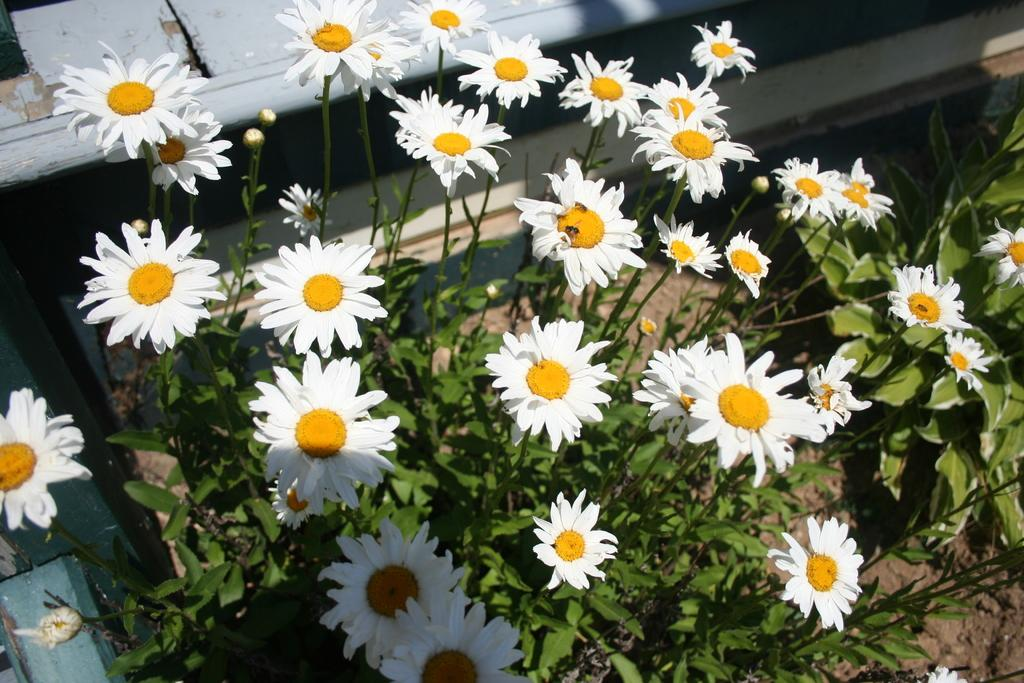What type of living organisms can be seen in the image? Flowers and plants are visible in the image. Can you describe the specific types of plants in the image? Unfortunately, the provided facts do not specify the types of plants in the image. What type of popcorn can be seen growing on the top of the plants in the image? There is no popcorn present in the image, and popcorn does not grow on plants. 